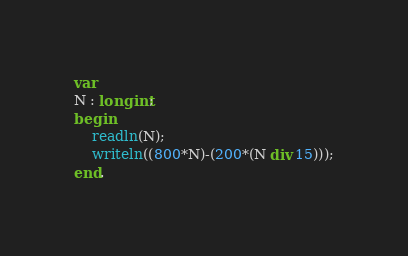<code> <loc_0><loc_0><loc_500><loc_500><_Pascal_>var
N : longint;
begin
	readln(N);
	writeln((800*N)-(200*(N div 15)));
end.</code> 